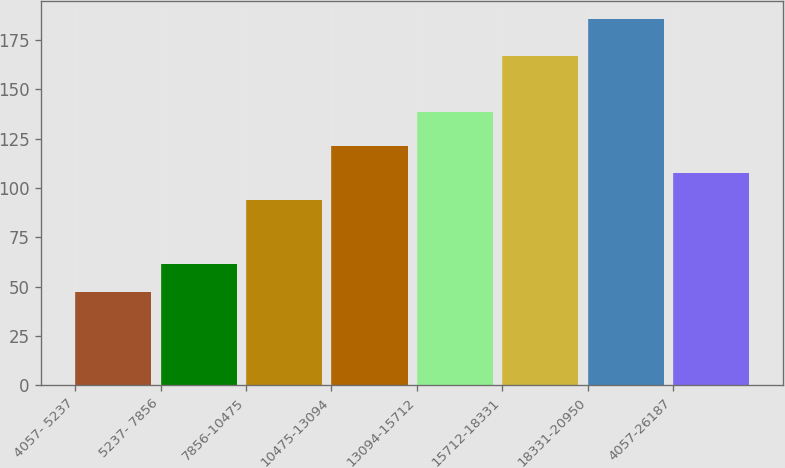Convert chart. <chart><loc_0><loc_0><loc_500><loc_500><bar_chart><fcel>4057- 5237<fcel>5237- 7856<fcel>7856-10475<fcel>10475-13094<fcel>13094-15712<fcel>15712-18331<fcel>18331-20950<fcel>4057-26187<nl><fcel>47.38<fcel>61.19<fcel>93.83<fcel>121.45<fcel>138.27<fcel>166.74<fcel>185.47<fcel>107.64<nl></chart> 